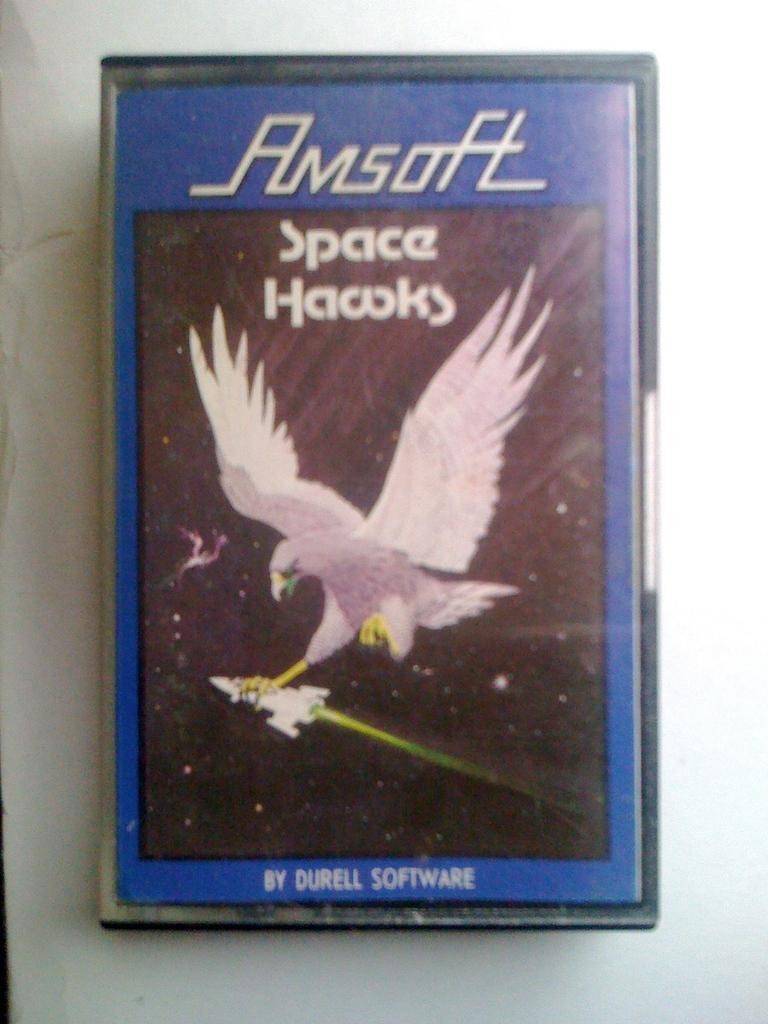What is the main subject of the image? There is an object in the image. What can be seen on the cover of the object? The cover of the object has a white color bird on it. Is there any text on the cover of the object? Yes, there is writing on the cover of the object. On what surface is the object placed? The object is placed on a white color surface. What type of cream is being used to support the ship in the image? There is no cream or ship present in the image. 